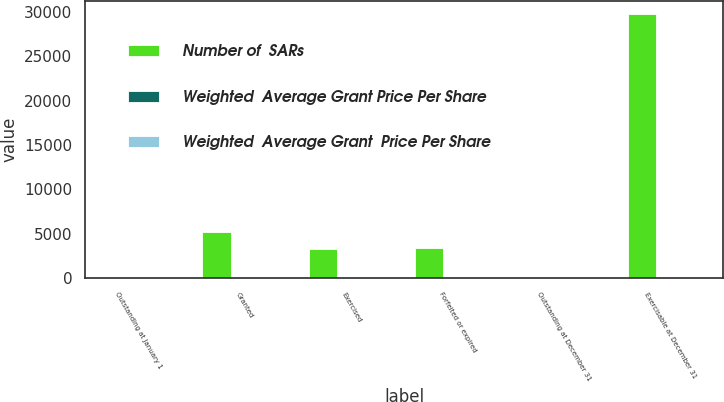<chart> <loc_0><loc_0><loc_500><loc_500><stacked_bar_chart><ecel><fcel>Outstanding at January 1<fcel>Granted<fcel>Exercised<fcel>Forfeited or expired<fcel>Outstanding at December 31<fcel>Exercisable at December 31<nl><fcel>Number of  SARs<fcel>20.805<fcel>5219<fcel>3242<fcel>3438<fcel>20.805<fcel>29721<nl><fcel>Weighted  Average Grant Price Per Share<fcel>19.79<fcel>18.99<fcel>13.59<fcel>32.96<fcel>19.14<fcel>19.71<nl><fcel>Weighted  Average Grant  Price Per Share<fcel>19.98<fcel>21.63<fcel>13.63<fcel>34.19<fcel>19.79<fcel>21.71<nl></chart> 